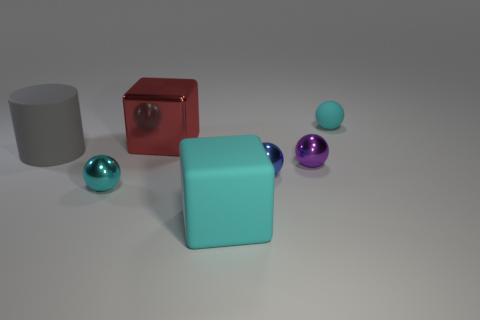Subtract all metal spheres. How many spheres are left? 1 Add 2 tiny rubber balls. How many objects exist? 9 Subtract all red blocks. How many blocks are left? 1 Subtract 1 spheres. How many spheres are left? 3 Subtract all blue cylinders. Subtract all gray blocks. How many cylinders are left? 1 Subtract all brown cubes. How many cyan spheres are left? 2 Subtract all brown matte balls. Subtract all big red objects. How many objects are left? 6 Add 2 big metal blocks. How many big metal blocks are left? 3 Add 7 gray rubber objects. How many gray rubber objects exist? 8 Subtract 0 yellow blocks. How many objects are left? 7 